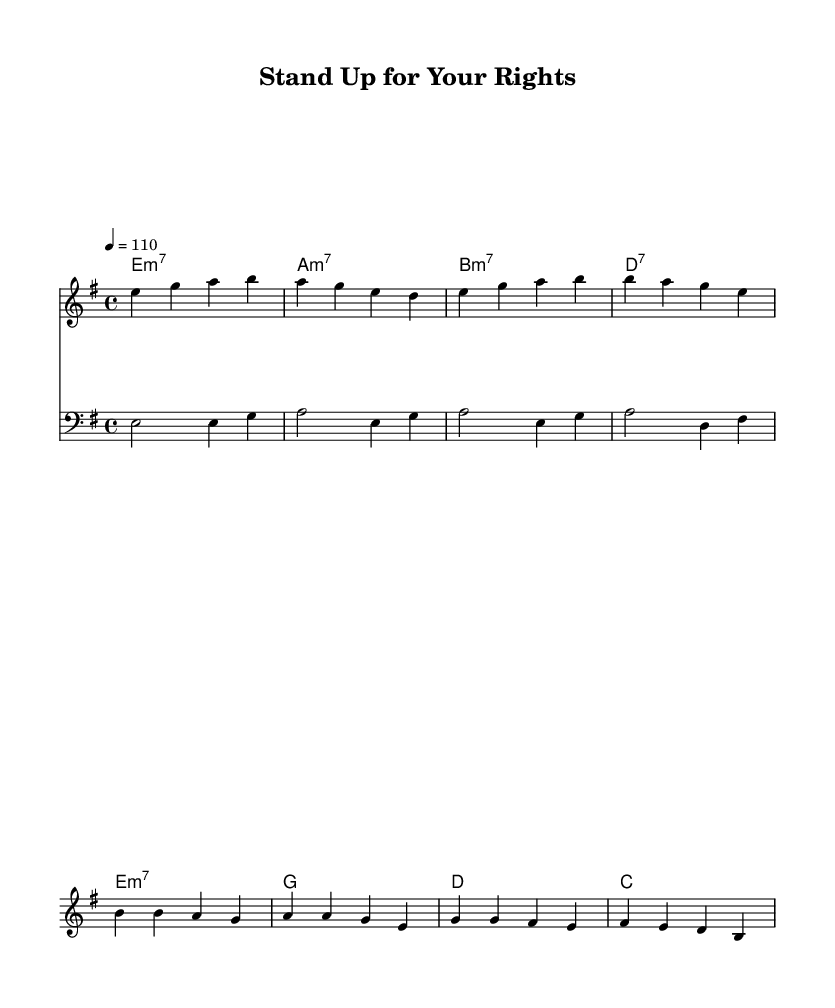What is the key signature of this music? The key signature is E minor, which is indicated by one sharp (F#). The presence of the E minor key at the beginning of the music confirms this.
Answer: E minor What is the time signature of this piece? The time signature is 4/4, which is shown at the beginning of the sheet music after the key signature. This means there are four beats in each measure.
Answer: 4/4 What is the tempo marking for this piece? The tempo marking is set to "4 = 110," indicating that there should be 110 beats per minute. This tempo marking appears in the global section at the beginning of the score.
Answer: 110 What are the first two notes of the melody in the verse? The first two notes are E and G; these notes appear at the beginning of the melodyVerse section. They establish the opening phrase of the verse.
Answer: E, G How many measures does the chorus consist of? The chorus consists of four measures, which can be counted from the melodyChorus section where four distinct sequences of notes are divided into four measures.
Answer: Four measures What is the primary theme reflected in the lyrics of the chorus? The primary theme is social justice, as the lyrics explicitly talk about standing up for rights and fighting for equality, which is a key aspect of the Funk genre's messaging in the 1970s.
Answer: Social justice 